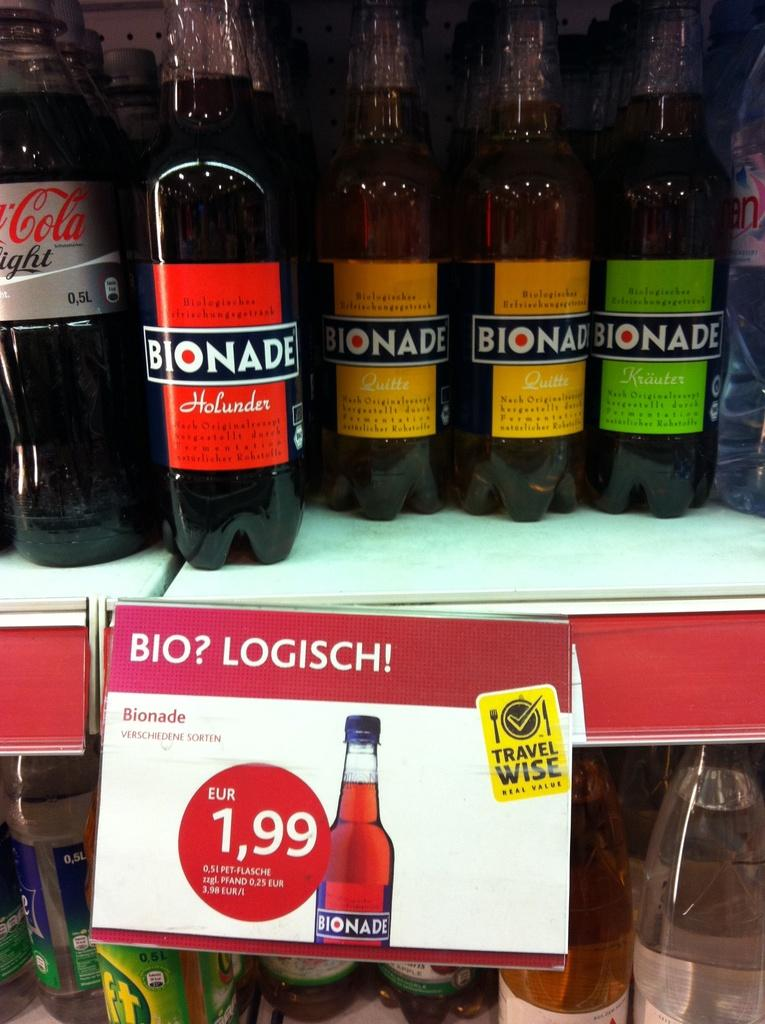What objects are visible in the image? There are drink bottles in the image. Where are the drink bottles located? The drink bottles are placed on a shelf. What additional information is provided in the image? There is a name plate in the image that provides information about the bottles. What type of information is mentioned on the name plate? The name plate mentions a price regarding the bottles. What type of nail design is visible on the birthday cake in the image? There is no birthday cake or nail design present in the image; it only features drink bottles, a shelf, and a name plate. 